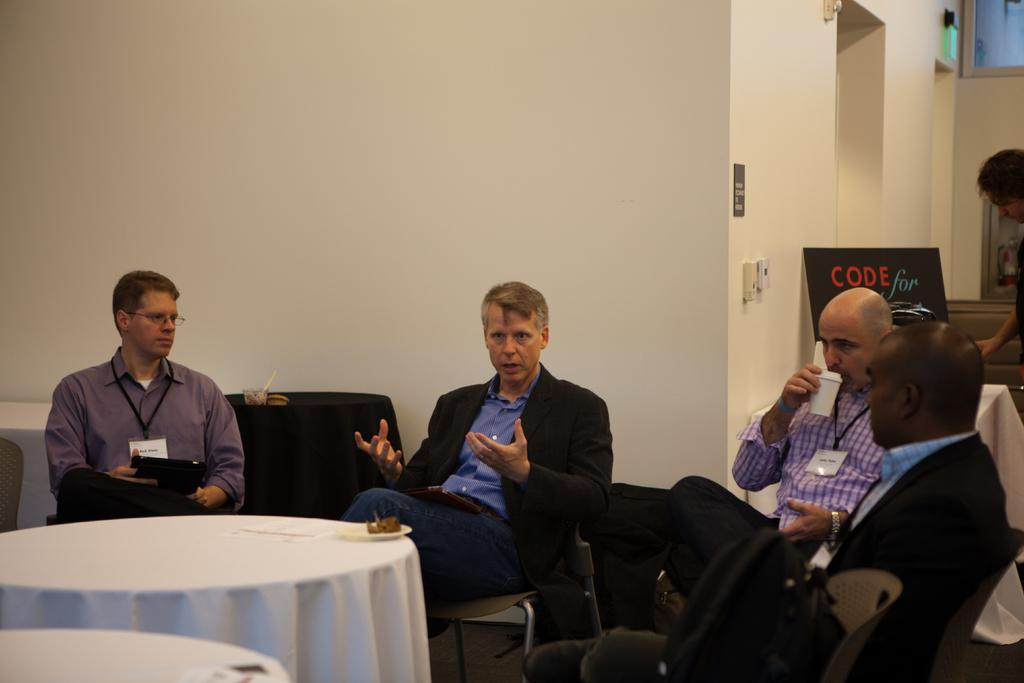What are the men in the image doing? The men in the image are sitting on chairs. What else can be seen in the image besides the men? There are tables in the image. Can you describe the person in the background of the image? There is a person in the background of the image, but no specific details are provided. What type of mask is the volcano wearing in the image? There is no volcano or mask present in the image. 